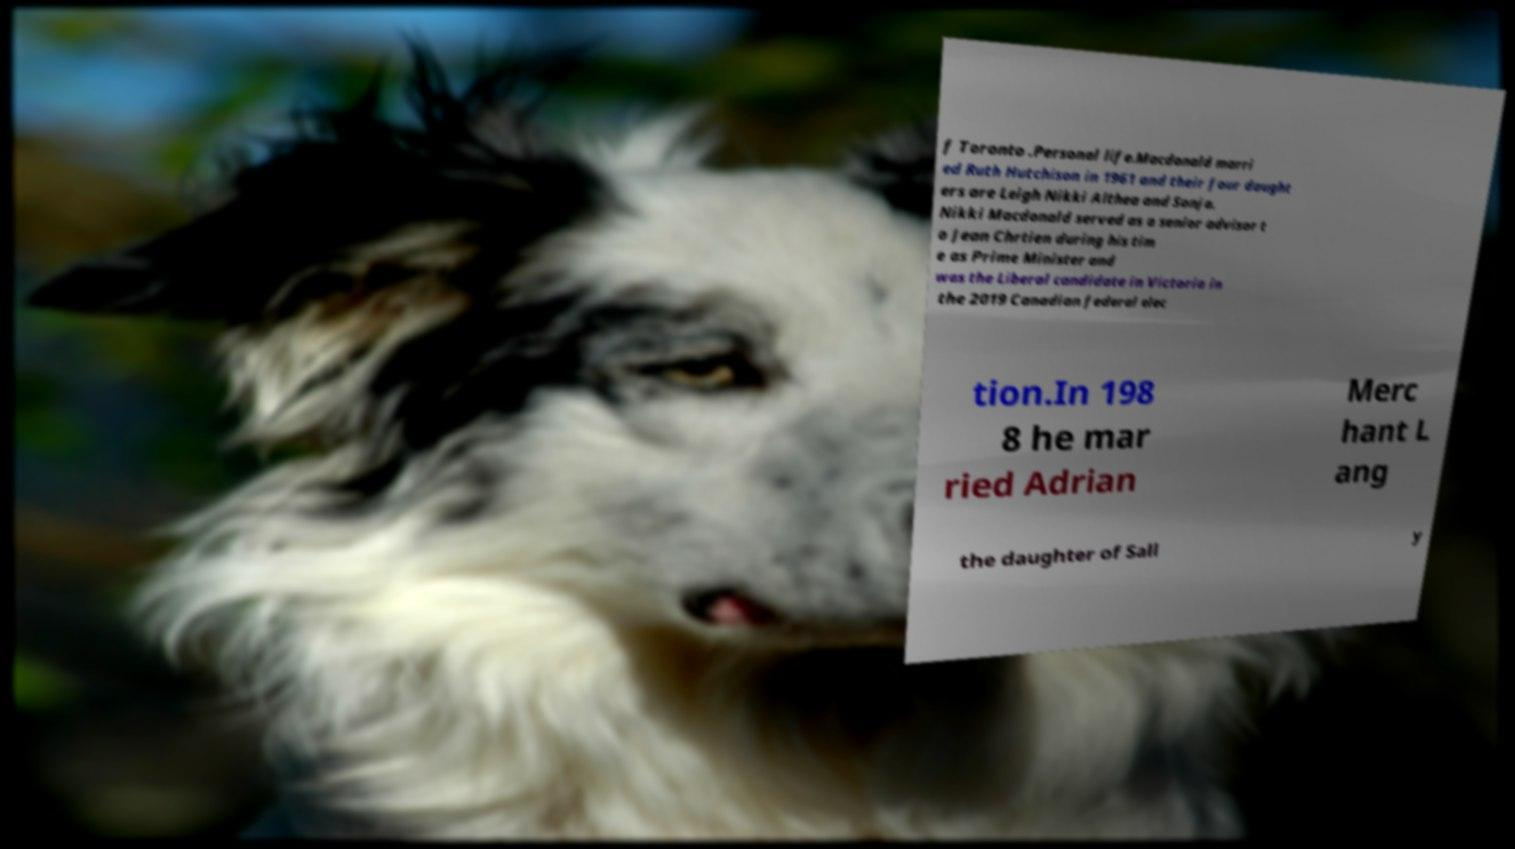Could you assist in decoding the text presented in this image and type it out clearly? f Toronto .Personal life.Macdonald marri ed Ruth Hutchison in 1961 and their four daught ers are Leigh Nikki Althea and Sonja. Nikki Macdonald served as a senior advisor t o Jean Chrtien during his tim e as Prime Minister and was the Liberal candidate in Victoria in the 2019 Canadian federal elec tion.In 198 8 he mar ried Adrian Merc hant L ang the daughter of Sall y 